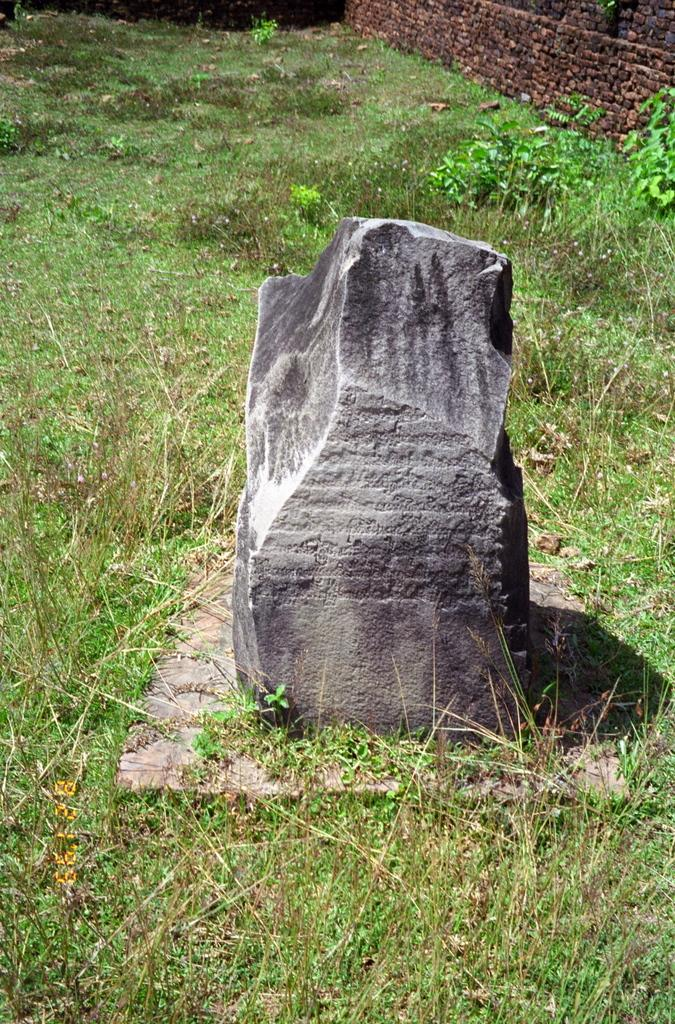What type of vegetation is present in the image? There is grass and plants in the image. What can be seen in the background of the image? There is a wall in the image. Are there any natural elements in the image? Yes, there is a rock in the image. What type of sound can be heard coming from the rock in the image? There is no sound coming from the rock in the image, as rocks do not produce sound. Is there a scarf draped over the grass in the image? There is no scarf present in the image. 